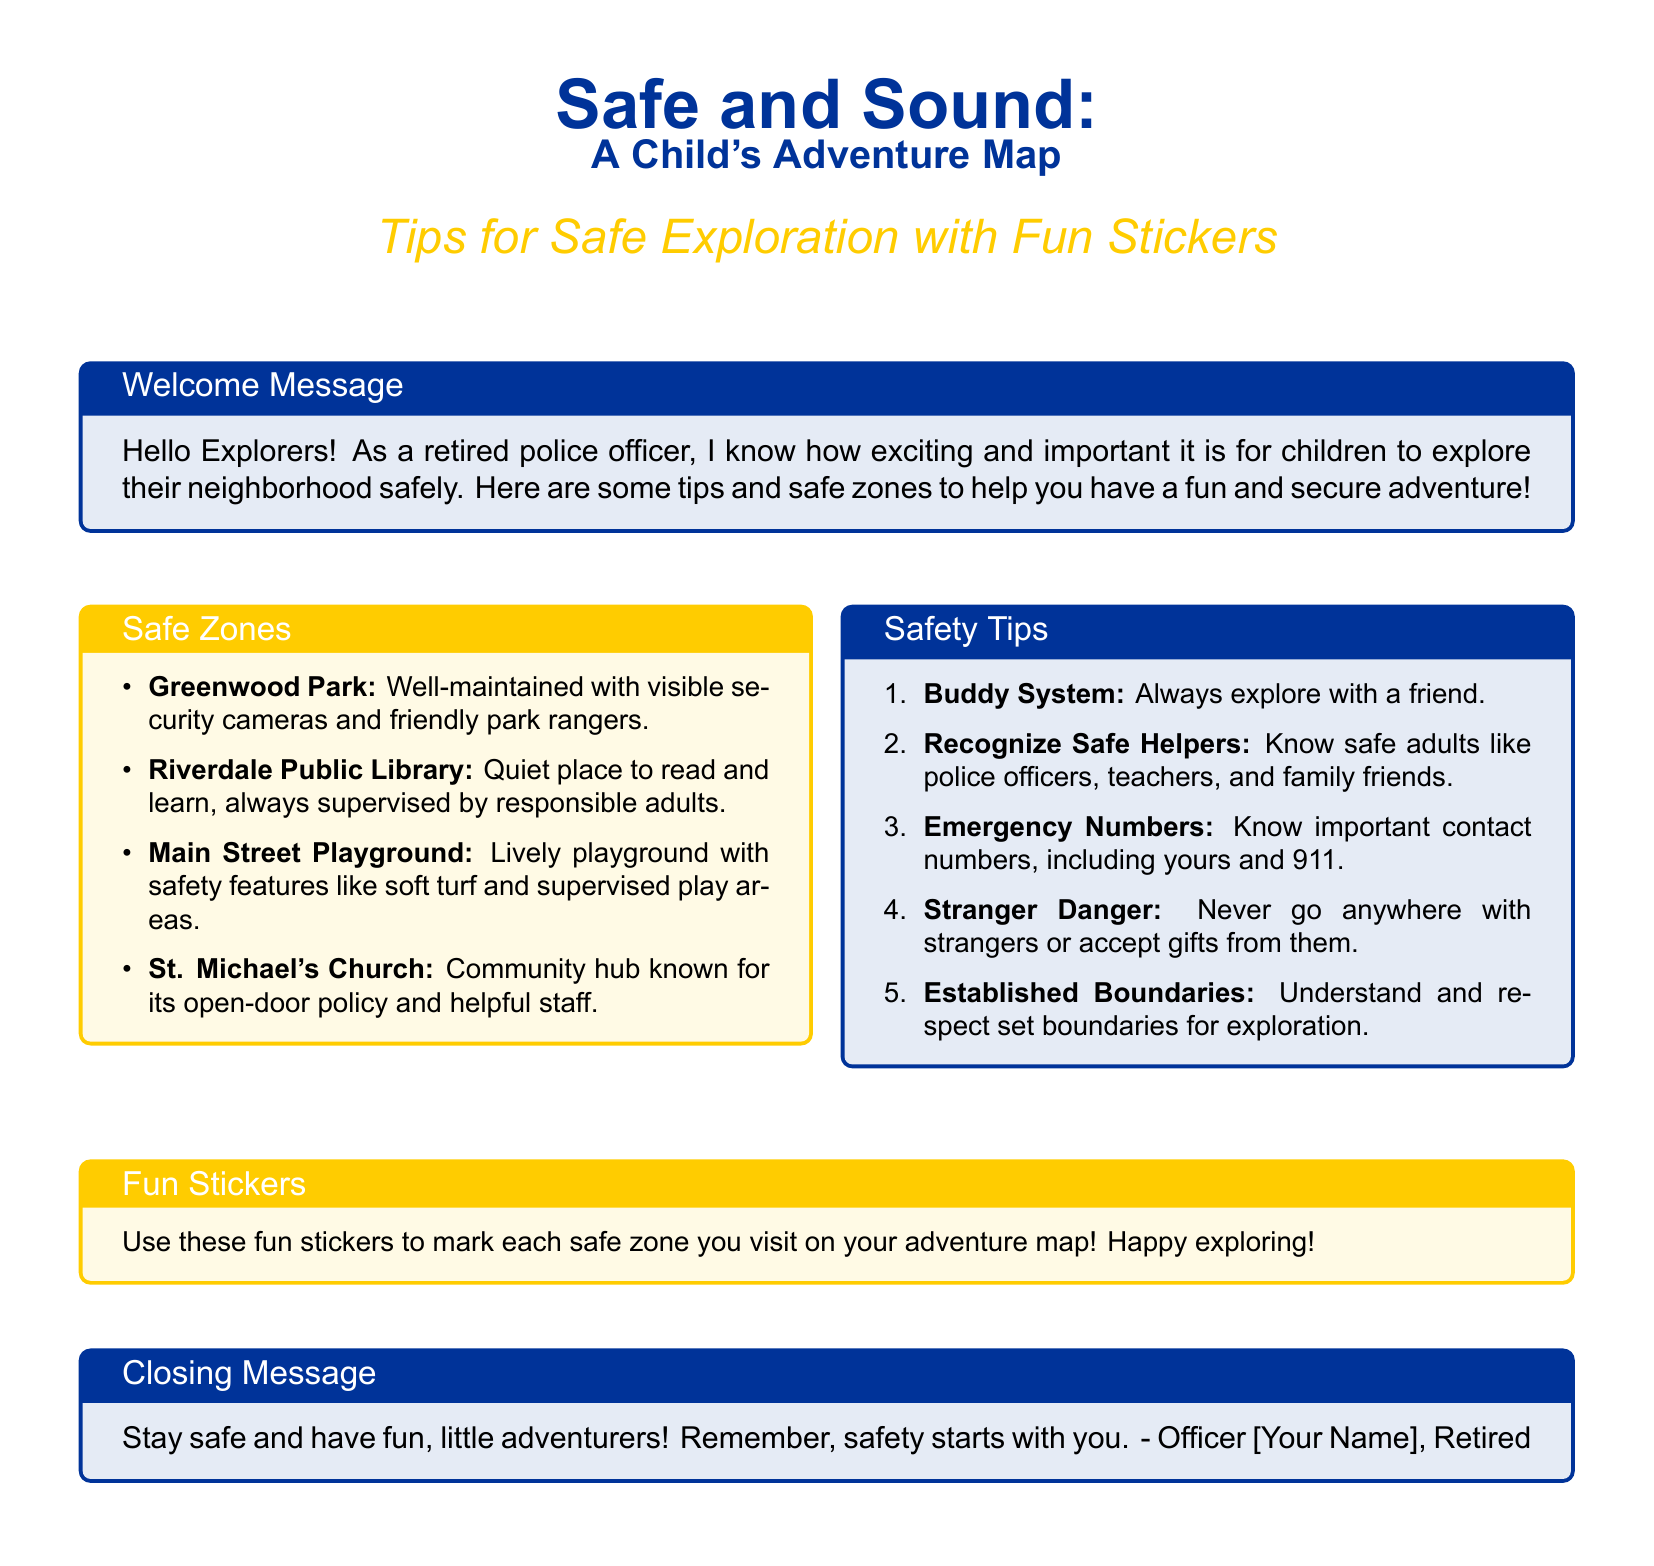What is the title of the document? The title is stated at the top of the document as "Safe and Sound: A Child's Adventure Map."
Answer: Safe and Sound: A Child's Adventure Map What color covers the safe zones box? The safe zones box has a yellow background, labeled with "colback=safeyellow!10."
Answer: Yellow How many safety tips are listed in the document? The document outlines five safety tips in the enumerated list.
Answer: Five Name one of the safe zones mentioned. The document lists multiple safe zones, such as "Greenwood Park."
Answer: Greenwood Park What does the closing message remind children? The closing message emphasizes that safety starts with the child.
Answer: Safety starts with you Which system is recommended for exploring safely? The document suggests the "Buddy System" as a safety measure during exploration.
Answer: Buddy System What type of document is this? This document is a greeting card designed to provide safety tips and information for children exploring their neighborhood.
Answer: Greeting card Who authored the document? The closing message indicates that the author is a retired police officer, labeled as "Officer [Your Name]."
Answer: Officer [Your Name] What should children use to mark the safe zones? The document suggests using "fun stickers" to mark each safe zone on their adventure map.
Answer: Fun stickers 